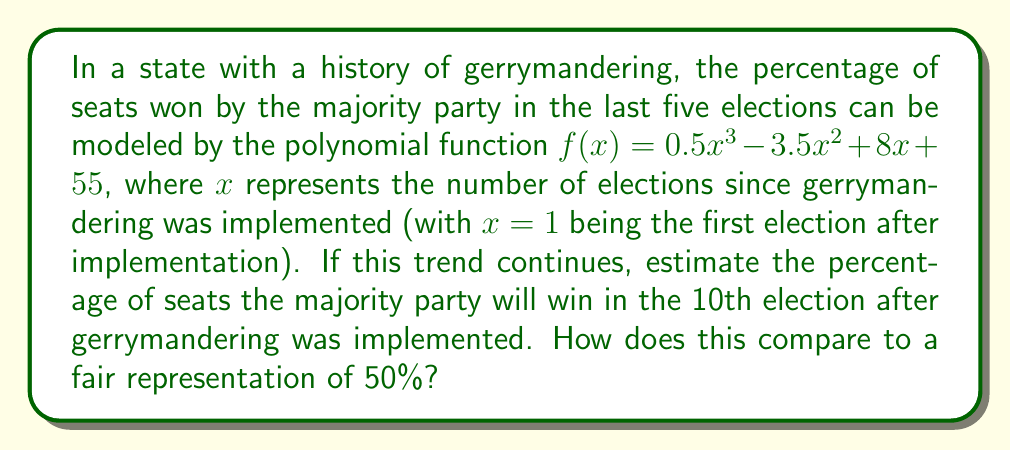Provide a solution to this math problem. To solve this problem, we'll follow these steps:

1) We're given the polynomial function:
   $f(x) = 0.5x^3 - 3.5x^2 + 8x + 55$

2) We need to find $f(10)$, as this represents the 10th election:

3) Let's substitute $x = 10$ into the function:
   $f(10) = 0.5(10)^3 - 3.5(10)^2 + 8(10) + 55$

4) Now, let's calculate each term:
   $0.5(10)^3 = 0.5(1000) = 500$
   $-3.5(10)^2 = -3.5(100) = -350$
   $8(10) = 80$
   $55$ remains as is

5) Sum all terms:
   $f(10) = 500 - 350 + 80 + 55 = 285$

6) This means the majority party is estimated to win 285% of the seats, which is impossible as it exceeds 100%.

7) This result indicates that the polynomial model breaks down for larger values of $x$ and shouldn't be used for long-term predictions without additional constraints or adjustments.

8) Comparing to a fair representation of 50%:
   $285\% - 50\% = 235\%$
   The model predicts a grossly inflated majority, 235 percentage points above fair representation.

This unrealistic result underscores the potential long-term dangers of unchecked gerrymandering and the limitations of simple polynomial models in predicting complex political phenomena.
Answer: 285%; 235 percentage points above fair representation 